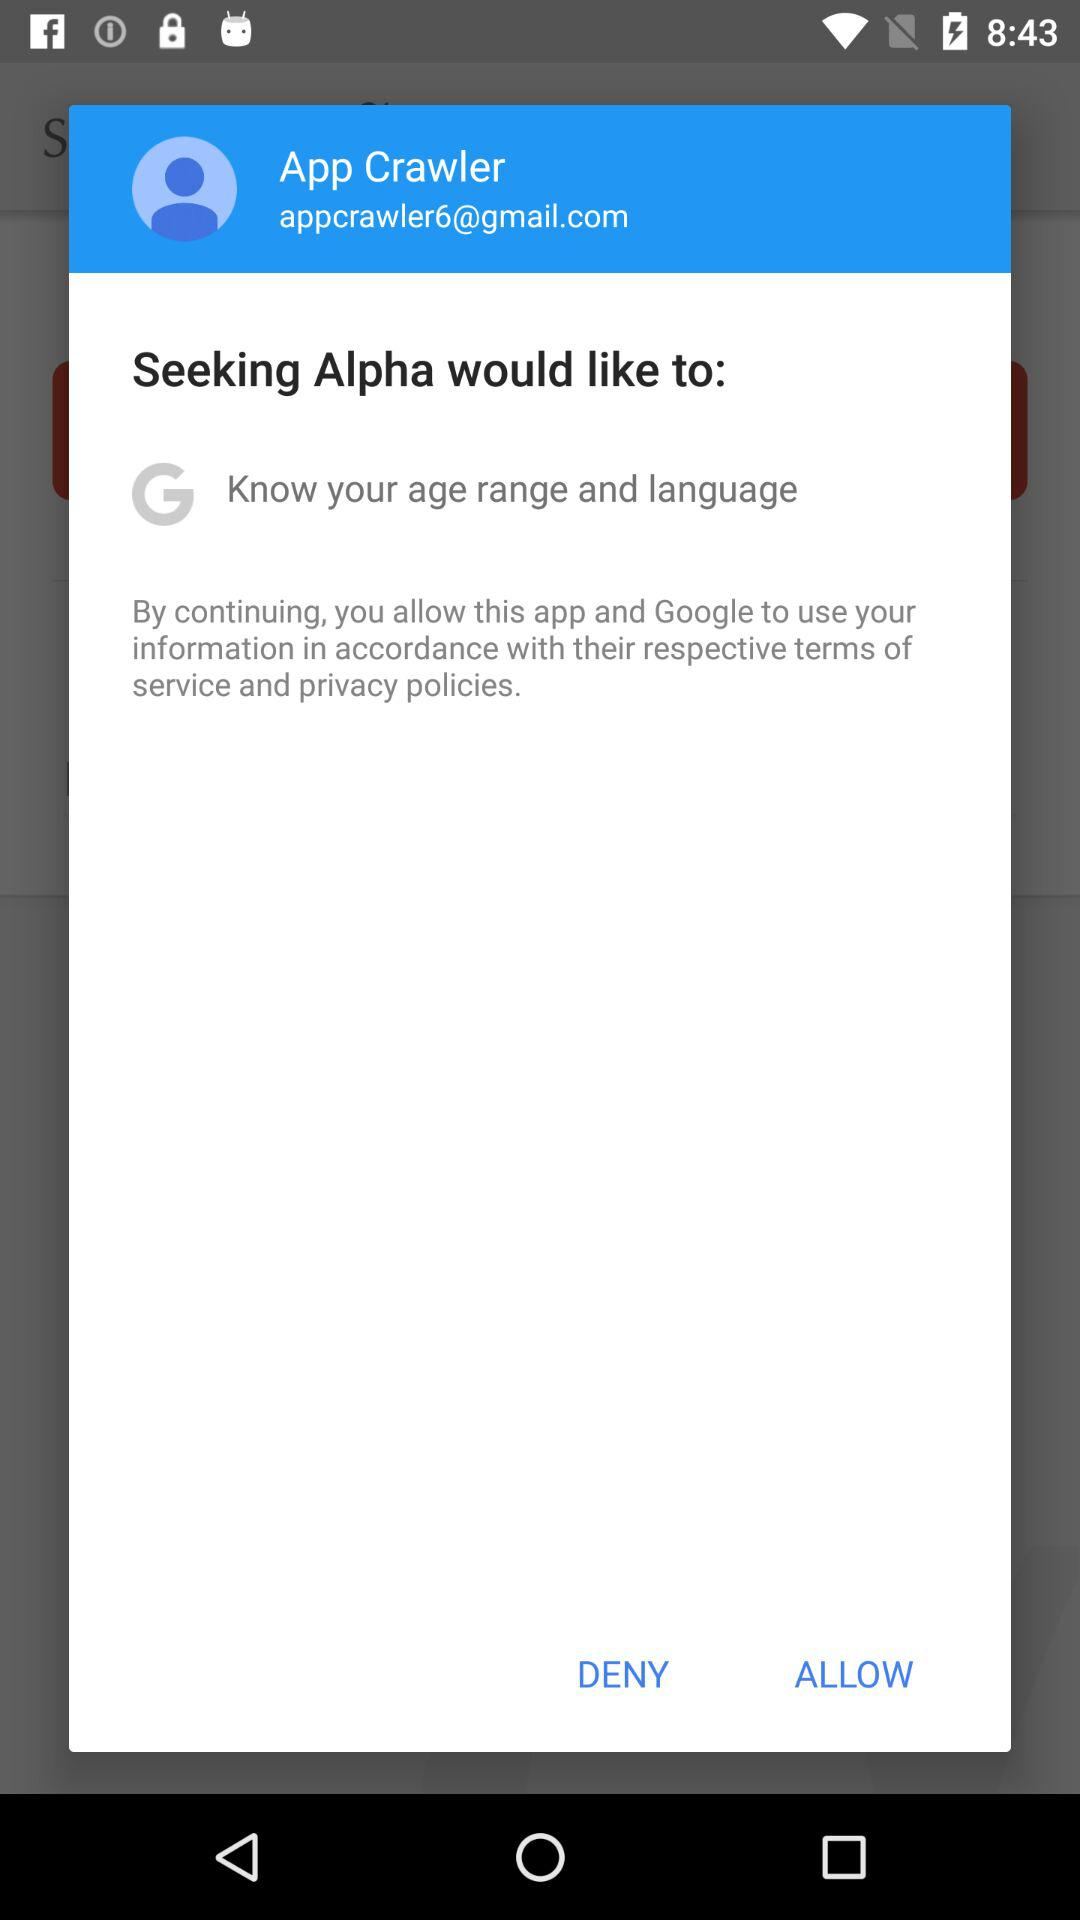What is an email address? The email address is "appcrawler6@gmail.com". 